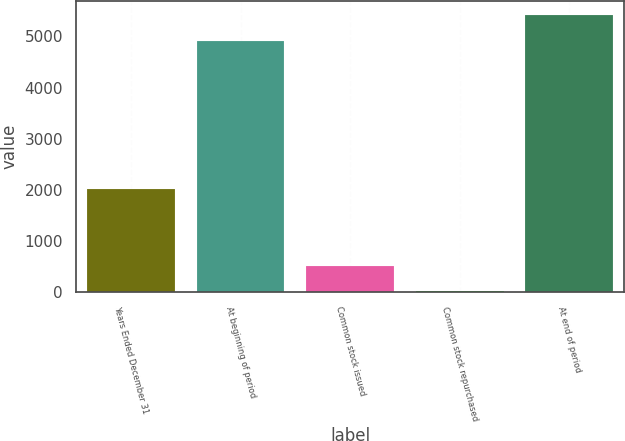Convert chart. <chart><loc_0><loc_0><loc_500><loc_500><bar_chart><fcel>Years Ended December 31<fcel>At beginning of period<fcel>Common stock issued<fcel>Common stock repurchased<fcel>At end of period<nl><fcel>2017<fcel>4916<fcel>514.5<fcel>14<fcel>5416.5<nl></chart> 